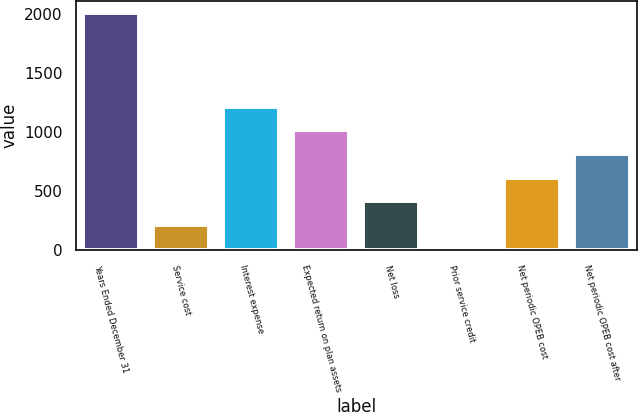<chart> <loc_0><loc_0><loc_500><loc_500><bar_chart><fcel>Years Ended December 31<fcel>Service cost<fcel>Interest expense<fcel>Expected return on plan assets<fcel>Net loss<fcel>Prior service credit<fcel>Net periodic OPEB cost<fcel>Net periodic OPEB cost after<nl><fcel>2011<fcel>219.1<fcel>1214.6<fcel>1015.5<fcel>418.2<fcel>20<fcel>617.3<fcel>816.4<nl></chart> 